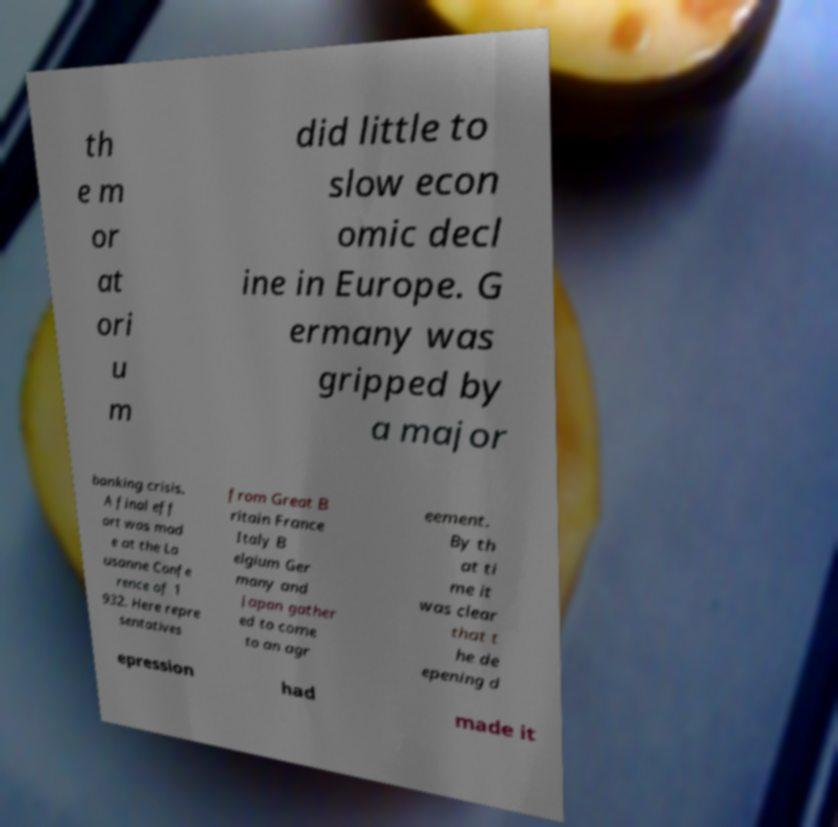Please identify and transcribe the text found in this image. th e m or at ori u m did little to slow econ omic decl ine in Europe. G ermany was gripped by a major banking crisis. A final eff ort was mad e at the La usanne Confe rence of 1 932. Here repre sentatives from Great B ritain France Italy B elgium Ger many and Japan gather ed to come to an agr eement. By th at ti me it was clear that t he de epening d epression had made it 